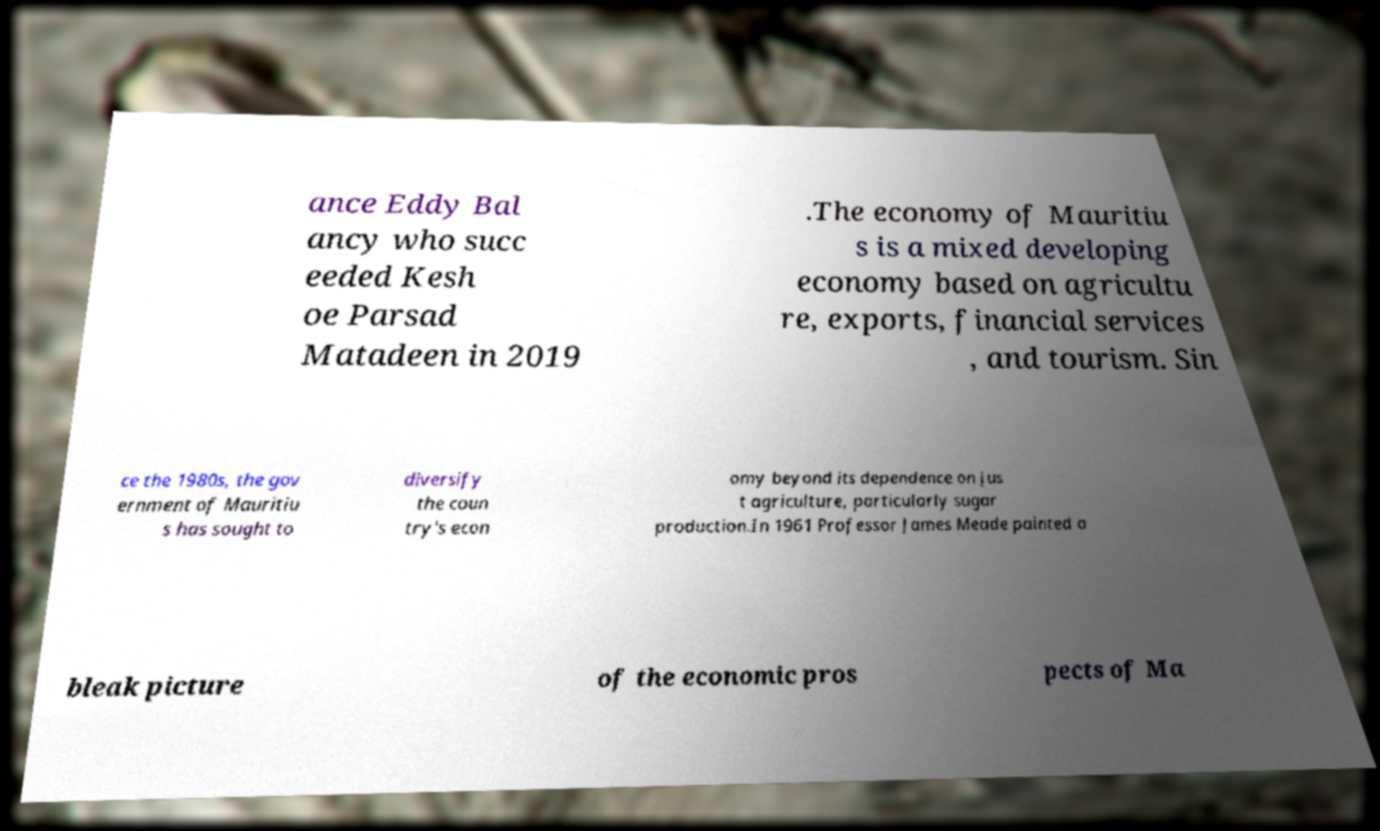Could you extract and type out the text from this image? ance Eddy Bal ancy who succ eeded Kesh oe Parsad Matadeen in 2019 .The economy of Mauritiu s is a mixed developing economy based on agricultu re, exports, financial services , and tourism. Sin ce the 1980s, the gov ernment of Mauritiu s has sought to diversify the coun try's econ omy beyond its dependence on jus t agriculture, particularly sugar production.In 1961 Professor James Meade painted a bleak picture of the economic pros pects of Ma 